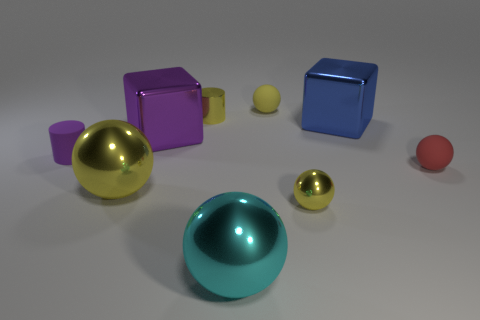Subtract all blue cylinders. How many yellow balls are left? 3 Subtract all rubber balls. How many balls are left? 3 Add 1 large cyan balls. How many objects exist? 10 Subtract 1 spheres. How many spheres are left? 4 Subtract all cyan balls. How many balls are left? 4 Subtract all blue balls. Subtract all cyan cylinders. How many balls are left? 5 Subtract all cubes. How many objects are left? 7 Add 1 big shiny blocks. How many big shiny blocks are left? 3 Add 9 big yellow balls. How many big yellow balls exist? 10 Subtract 0 cyan blocks. How many objects are left? 9 